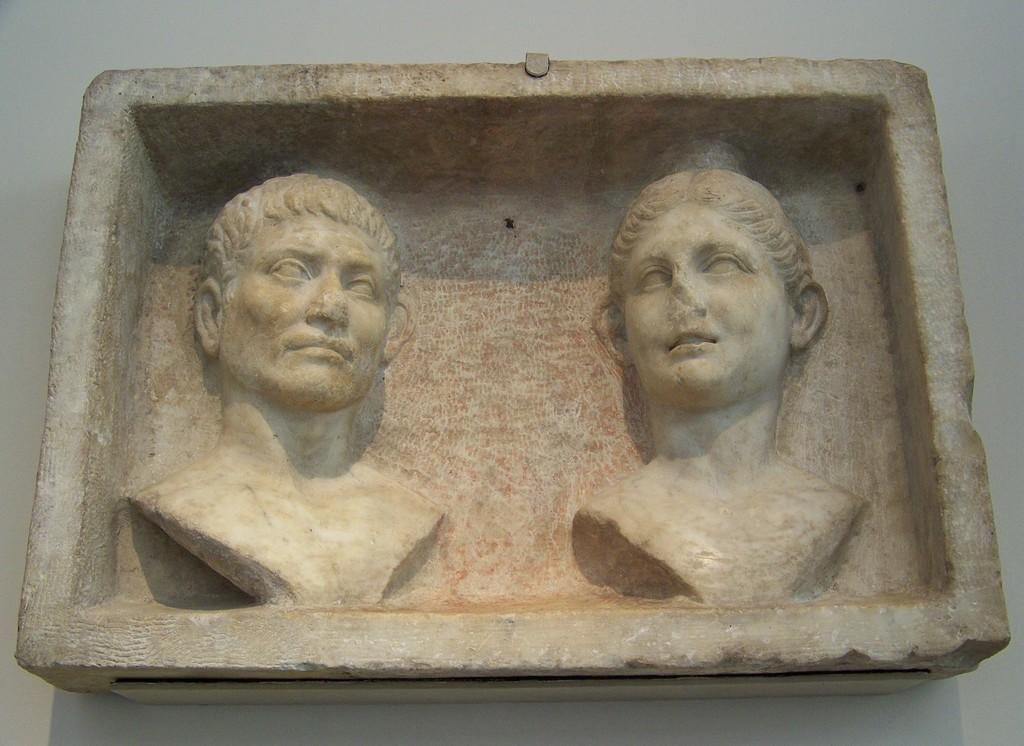What is the main subject in the image? There is a stone carving in the image. Can you describe the stone carving in more detail? The stone carving is placed on a surface. What type of iron is used to create the stone carving in the image? There is no iron used in the creation of the stone carving in the image; it is made of stone. How does the stone carving turn into a different shape in the image? The stone carving does not change shape or turn into a different shape in the image; it remains stationary. 